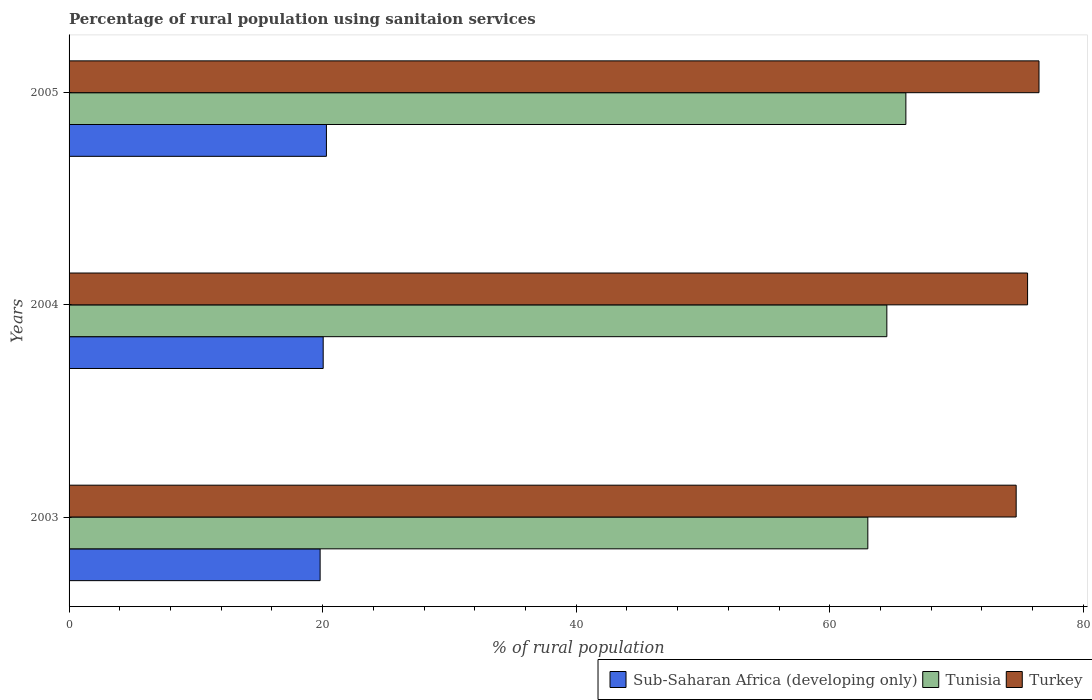How many different coloured bars are there?
Provide a succinct answer. 3. How many groups of bars are there?
Your answer should be very brief. 3. Are the number of bars per tick equal to the number of legend labels?
Make the answer very short. Yes. Are the number of bars on each tick of the Y-axis equal?
Your answer should be compact. Yes. How many bars are there on the 3rd tick from the top?
Offer a terse response. 3. What is the label of the 3rd group of bars from the top?
Offer a terse response. 2003. In how many cases, is the number of bars for a given year not equal to the number of legend labels?
Your response must be concise. 0. What is the percentage of rural population using sanitaion services in Sub-Saharan Africa (developing only) in 2003?
Provide a succinct answer. 19.8. Across all years, what is the maximum percentage of rural population using sanitaion services in Sub-Saharan Africa (developing only)?
Ensure brevity in your answer.  20.3. In which year was the percentage of rural population using sanitaion services in Sub-Saharan Africa (developing only) maximum?
Provide a succinct answer. 2005. In which year was the percentage of rural population using sanitaion services in Turkey minimum?
Provide a succinct answer. 2003. What is the total percentage of rural population using sanitaion services in Turkey in the graph?
Provide a succinct answer. 226.8. What is the difference between the percentage of rural population using sanitaion services in Tunisia in 2003 and that in 2005?
Ensure brevity in your answer.  -3. What is the difference between the percentage of rural population using sanitaion services in Sub-Saharan Africa (developing only) in 2005 and the percentage of rural population using sanitaion services in Tunisia in 2003?
Ensure brevity in your answer.  -42.7. What is the average percentage of rural population using sanitaion services in Tunisia per year?
Your answer should be very brief. 64.5. In the year 2005, what is the difference between the percentage of rural population using sanitaion services in Turkey and percentage of rural population using sanitaion services in Sub-Saharan Africa (developing only)?
Your response must be concise. 56.2. In how many years, is the percentage of rural population using sanitaion services in Tunisia greater than 72 %?
Give a very brief answer. 0. What is the ratio of the percentage of rural population using sanitaion services in Tunisia in 2003 to that in 2004?
Provide a short and direct response. 0.98. What is the difference between the highest and the second highest percentage of rural population using sanitaion services in Turkey?
Ensure brevity in your answer.  0.9. What is the difference between the highest and the lowest percentage of rural population using sanitaion services in Turkey?
Your answer should be compact. 1.8. In how many years, is the percentage of rural population using sanitaion services in Tunisia greater than the average percentage of rural population using sanitaion services in Tunisia taken over all years?
Your response must be concise. 1. Is the sum of the percentage of rural population using sanitaion services in Tunisia in 2003 and 2005 greater than the maximum percentage of rural population using sanitaion services in Sub-Saharan Africa (developing only) across all years?
Offer a very short reply. Yes. What does the 2nd bar from the bottom in 2005 represents?
Give a very brief answer. Tunisia. How many bars are there?
Your response must be concise. 9. Are all the bars in the graph horizontal?
Make the answer very short. Yes. How many years are there in the graph?
Your response must be concise. 3. What is the difference between two consecutive major ticks on the X-axis?
Your answer should be very brief. 20. Are the values on the major ticks of X-axis written in scientific E-notation?
Your answer should be compact. No. Where does the legend appear in the graph?
Give a very brief answer. Bottom right. How are the legend labels stacked?
Offer a very short reply. Horizontal. What is the title of the graph?
Offer a terse response. Percentage of rural population using sanitaion services. What is the label or title of the X-axis?
Ensure brevity in your answer.  % of rural population. What is the % of rural population in Sub-Saharan Africa (developing only) in 2003?
Provide a short and direct response. 19.8. What is the % of rural population of Turkey in 2003?
Your response must be concise. 74.7. What is the % of rural population in Sub-Saharan Africa (developing only) in 2004?
Offer a very short reply. 20.04. What is the % of rural population in Tunisia in 2004?
Keep it short and to the point. 64.5. What is the % of rural population in Turkey in 2004?
Make the answer very short. 75.6. What is the % of rural population of Sub-Saharan Africa (developing only) in 2005?
Give a very brief answer. 20.3. What is the % of rural population of Turkey in 2005?
Provide a succinct answer. 76.5. Across all years, what is the maximum % of rural population in Sub-Saharan Africa (developing only)?
Provide a short and direct response. 20.3. Across all years, what is the maximum % of rural population in Turkey?
Make the answer very short. 76.5. Across all years, what is the minimum % of rural population of Sub-Saharan Africa (developing only)?
Provide a succinct answer. 19.8. Across all years, what is the minimum % of rural population in Tunisia?
Provide a succinct answer. 63. Across all years, what is the minimum % of rural population in Turkey?
Provide a succinct answer. 74.7. What is the total % of rural population of Sub-Saharan Africa (developing only) in the graph?
Make the answer very short. 60.14. What is the total % of rural population of Tunisia in the graph?
Make the answer very short. 193.5. What is the total % of rural population in Turkey in the graph?
Offer a terse response. 226.8. What is the difference between the % of rural population in Sub-Saharan Africa (developing only) in 2003 and that in 2004?
Give a very brief answer. -0.24. What is the difference between the % of rural population in Turkey in 2003 and that in 2004?
Your answer should be compact. -0.9. What is the difference between the % of rural population in Sub-Saharan Africa (developing only) in 2003 and that in 2005?
Provide a short and direct response. -0.5. What is the difference between the % of rural population of Tunisia in 2003 and that in 2005?
Provide a succinct answer. -3. What is the difference between the % of rural population of Sub-Saharan Africa (developing only) in 2004 and that in 2005?
Keep it short and to the point. -0.26. What is the difference between the % of rural population in Sub-Saharan Africa (developing only) in 2003 and the % of rural population in Tunisia in 2004?
Provide a succinct answer. -44.7. What is the difference between the % of rural population in Sub-Saharan Africa (developing only) in 2003 and the % of rural population in Turkey in 2004?
Offer a very short reply. -55.8. What is the difference between the % of rural population in Sub-Saharan Africa (developing only) in 2003 and the % of rural population in Tunisia in 2005?
Offer a terse response. -46.2. What is the difference between the % of rural population of Sub-Saharan Africa (developing only) in 2003 and the % of rural population of Turkey in 2005?
Give a very brief answer. -56.7. What is the difference between the % of rural population in Tunisia in 2003 and the % of rural population in Turkey in 2005?
Ensure brevity in your answer.  -13.5. What is the difference between the % of rural population in Sub-Saharan Africa (developing only) in 2004 and the % of rural population in Tunisia in 2005?
Keep it short and to the point. -45.96. What is the difference between the % of rural population in Sub-Saharan Africa (developing only) in 2004 and the % of rural population in Turkey in 2005?
Offer a very short reply. -56.46. What is the difference between the % of rural population of Tunisia in 2004 and the % of rural population of Turkey in 2005?
Your answer should be very brief. -12. What is the average % of rural population in Sub-Saharan Africa (developing only) per year?
Make the answer very short. 20.05. What is the average % of rural population in Tunisia per year?
Make the answer very short. 64.5. What is the average % of rural population of Turkey per year?
Your answer should be very brief. 75.6. In the year 2003, what is the difference between the % of rural population of Sub-Saharan Africa (developing only) and % of rural population of Tunisia?
Your answer should be very brief. -43.2. In the year 2003, what is the difference between the % of rural population of Sub-Saharan Africa (developing only) and % of rural population of Turkey?
Offer a terse response. -54.9. In the year 2004, what is the difference between the % of rural population of Sub-Saharan Africa (developing only) and % of rural population of Tunisia?
Make the answer very short. -44.46. In the year 2004, what is the difference between the % of rural population in Sub-Saharan Africa (developing only) and % of rural population in Turkey?
Offer a very short reply. -55.56. In the year 2005, what is the difference between the % of rural population of Sub-Saharan Africa (developing only) and % of rural population of Tunisia?
Your response must be concise. -45.7. In the year 2005, what is the difference between the % of rural population of Sub-Saharan Africa (developing only) and % of rural population of Turkey?
Offer a very short reply. -56.2. In the year 2005, what is the difference between the % of rural population in Tunisia and % of rural population in Turkey?
Offer a terse response. -10.5. What is the ratio of the % of rural population of Tunisia in 2003 to that in 2004?
Your answer should be compact. 0.98. What is the ratio of the % of rural population of Sub-Saharan Africa (developing only) in 2003 to that in 2005?
Your answer should be very brief. 0.98. What is the ratio of the % of rural population of Tunisia in 2003 to that in 2005?
Offer a very short reply. 0.95. What is the ratio of the % of rural population of Turkey in 2003 to that in 2005?
Ensure brevity in your answer.  0.98. What is the ratio of the % of rural population of Sub-Saharan Africa (developing only) in 2004 to that in 2005?
Your answer should be compact. 0.99. What is the ratio of the % of rural population in Tunisia in 2004 to that in 2005?
Keep it short and to the point. 0.98. What is the difference between the highest and the second highest % of rural population of Sub-Saharan Africa (developing only)?
Your answer should be compact. 0.26. What is the difference between the highest and the second highest % of rural population in Tunisia?
Make the answer very short. 1.5. What is the difference between the highest and the lowest % of rural population in Sub-Saharan Africa (developing only)?
Provide a short and direct response. 0.5. What is the difference between the highest and the lowest % of rural population in Turkey?
Your response must be concise. 1.8. 